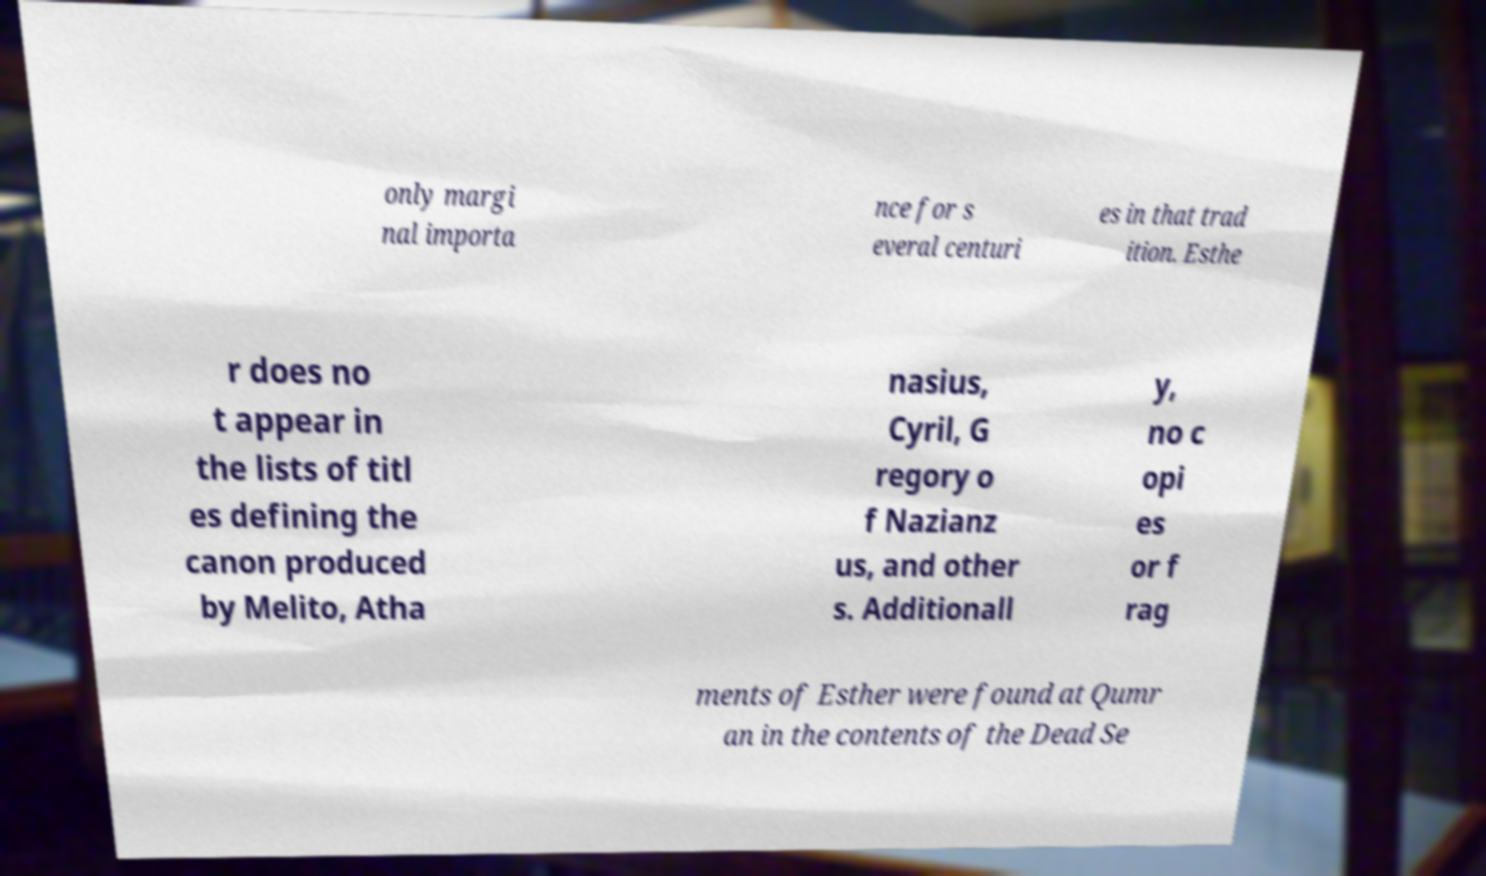I need the written content from this picture converted into text. Can you do that? only margi nal importa nce for s everal centuri es in that trad ition. Esthe r does no t appear in the lists of titl es defining the canon produced by Melito, Atha nasius, Cyril, G regory o f Nazianz us, and other s. Additionall y, no c opi es or f rag ments of Esther were found at Qumr an in the contents of the Dead Se 